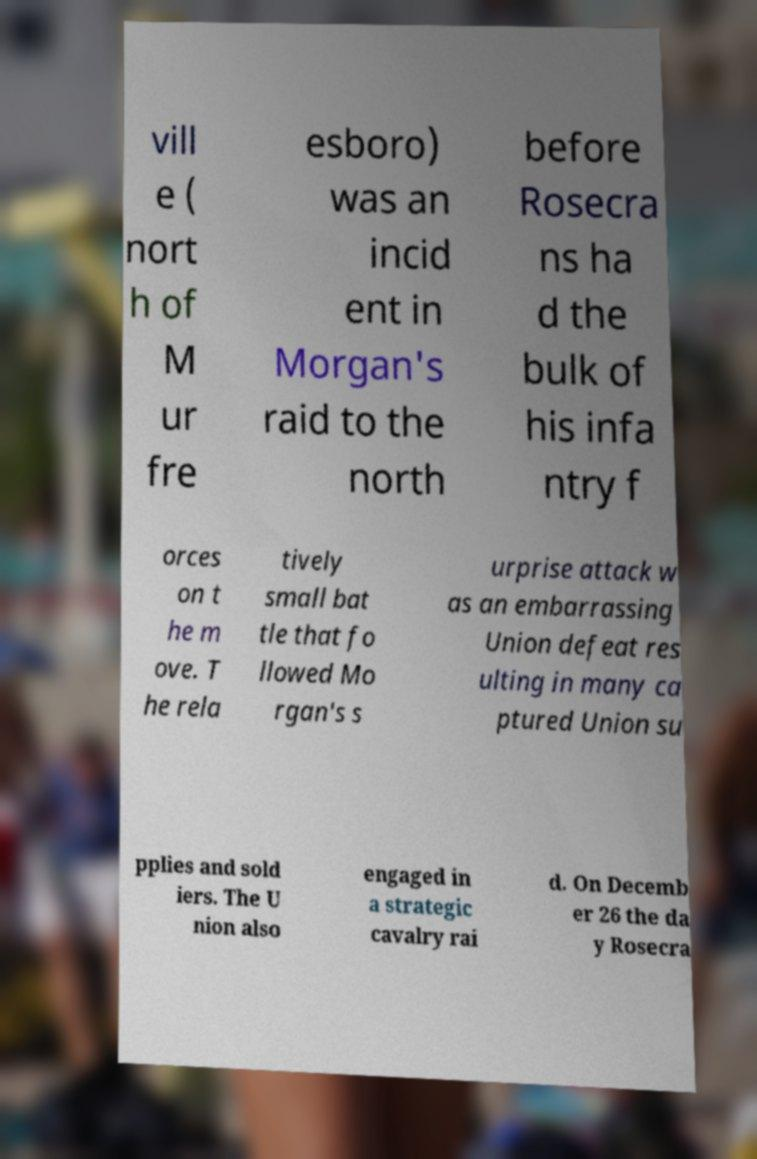Could you extract and type out the text from this image? vill e ( nort h of M ur fre esboro) was an incid ent in Morgan's raid to the north before Rosecra ns ha d the bulk of his infa ntry f orces on t he m ove. T he rela tively small bat tle that fo llowed Mo rgan's s urprise attack w as an embarrassing Union defeat res ulting in many ca ptured Union su pplies and sold iers. The U nion also engaged in a strategic cavalry rai d. On Decemb er 26 the da y Rosecra 